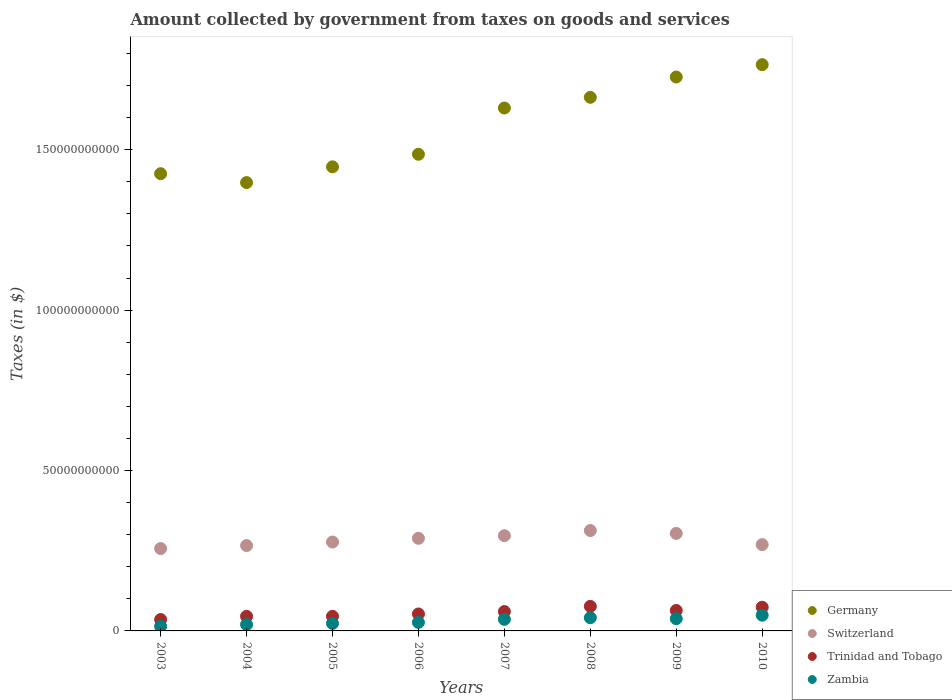What is the amount collected by government from taxes on goods and services in Zambia in 2006?
Your answer should be very brief. 2.66e+09. Across all years, what is the maximum amount collected by government from taxes on goods and services in Switzerland?
Keep it short and to the point. 3.13e+1. Across all years, what is the minimum amount collected by government from taxes on goods and services in Trinidad and Tobago?
Ensure brevity in your answer.  3.56e+09. In which year was the amount collected by government from taxes on goods and services in Germany maximum?
Keep it short and to the point. 2010. In which year was the amount collected by government from taxes on goods and services in Germany minimum?
Offer a very short reply. 2004. What is the total amount collected by government from taxes on goods and services in Switzerland in the graph?
Your response must be concise. 2.27e+11. What is the difference between the amount collected by government from taxes on goods and services in Zambia in 2005 and that in 2007?
Give a very brief answer. -1.28e+09. What is the difference between the amount collected by government from taxes on goods and services in Switzerland in 2005 and the amount collected by government from taxes on goods and services in Zambia in 2010?
Your response must be concise. 2.28e+1. What is the average amount collected by government from taxes on goods and services in Zambia per year?
Make the answer very short. 3.11e+09. In the year 2008, what is the difference between the amount collected by government from taxes on goods and services in Germany and amount collected by government from taxes on goods and services in Switzerland?
Offer a very short reply. 1.35e+11. In how many years, is the amount collected by government from taxes on goods and services in Switzerland greater than 90000000000 $?
Your answer should be compact. 0. What is the ratio of the amount collected by government from taxes on goods and services in Trinidad and Tobago in 2007 to that in 2009?
Offer a terse response. 0.95. What is the difference between the highest and the second highest amount collected by government from taxes on goods and services in Germany?
Ensure brevity in your answer.  3.85e+09. What is the difference between the highest and the lowest amount collected by government from taxes on goods and services in Germany?
Your response must be concise. 3.68e+1. Is it the case that in every year, the sum of the amount collected by government from taxes on goods and services in Switzerland and amount collected by government from taxes on goods and services in Zambia  is greater than the sum of amount collected by government from taxes on goods and services in Germany and amount collected by government from taxes on goods and services in Trinidad and Tobago?
Ensure brevity in your answer.  No. Is it the case that in every year, the sum of the amount collected by government from taxes on goods and services in Zambia and amount collected by government from taxes on goods and services in Germany  is greater than the amount collected by government from taxes on goods and services in Switzerland?
Offer a very short reply. Yes. Does the amount collected by government from taxes on goods and services in Trinidad and Tobago monotonically increase over the years?
Provide a short and direct response. No. Is the amount collected by government from taxes on goods and services in Germany strictly less than the amount collected by government from taxes on goods and services in Zambia over the years?
Provide a short and direct response. No. How many dotlines are there?
Make the answer very short. 4. What is the difference between two consecutive major ticks on the Y-axis?
Offer a very short reply. 5.00e+1. Are the values on the major ticks of Y-axis written in scientific E-notation?
Your response must be concise. No. How many legend labels are there?
Offer a terse response. 4. What is the title of the graph?
Provide a short and direct response. Amount collected by government from taxes on goods and services. What is the label or title of the X-axis?
Offer a very short reply. Years. What is the label or title of the Y-axis?
Your answer should be very brief. Taxes (in $). What is the Taxes (in $) of Germany in 2003?
Your answer should be very brief. 1.43e+11. What is the Taxes (in $) in Switzerland in 2003?
Offer a very short reply. 2.57e+1. What is the Taxes (in $) of Trinidad and Tobago in 2003?
Provide a short and direct response. 3.56e+09. What is the Taxes (in $) in Zambia in 2003?
Your answer should be compact. 1.42e+09. What is the Taxes (in $) in Germany in 2004?
Provide a short and direct response. 1.40e+11. What is the Taxes (in $) in Switzerland in 2004?
Make the answer very short. 2.66e+1. What is the Taxes (in $) in Trinidad and Tobago in 2004?
Your answer should be compact. 4.55e+09. What is the Taxes (in $) in Zambia in 2004?
Offer a very short reply. 1.99e+09. What is the Taxes (in $) of Germany in 2005?
Keep it short and to the point. 1.45e+11. What is the Taxes (in $) in Switzerland in 2005?
Offer a terse response. 2.77e+1. What is the Taxes (in $) in Trinidad and Tobago in 2005?
Provide a short and direct response. 4.56e+09. What is the Taxes (in $) of Zambia in 2005?
Give a very brief answer. 2.34e+09. What is the Taxes (in $) of Germany in 2006?
Give a very brief answer. 1.49e+11. What is the Taxes (in $) of Switzerland in 2006?
Ensure brevity in your answer.  2.89e+1. What is the Taxes (in $) of Trinidad and Tobago in 2006?
Provide a succinct answer. 5.29e+09. What is the Taxes (in $) of Zambia in 2006?
Your answer should be compact. 2.66e+09. What is the Taxes (in $) in Germany in 2007?
Your response must be concise. 1.63e+11. What is the Taxes (in $) in Switzerland in 2007?
Your response must be concise. 2.97e+1. What is the Taxes (in $) of Trinidad and Tobago in 2007?
Your response must be concise. 6.04e+09. What is the Taxes (in $) in Zambia in 2007?
Make the answer very short. 3.62e+09. What is the Taxes (in $) of Germany in 2008?
Ensure brevity in your answer.  1.66e+11. What is the Taxes (in $) in Switzerland in 2008?
Keep it short and to the point. 3.13e+1. What is the Taxes (in $) of Trinidad and Tobago in 2008?
Make the answer very short. 7.66e+09. What is the Taxes (in $) in Zambia in 2008?
Provide a succinct answer. 4.11e+09. What is the Taxes (in $) of Germany in 2009?
Give a very brief answer. 1.73e+11. What is the Taxes (in $) of Switzerland in 2009?
Provide a short and direct response. 3.04e+1. What is the Taxes (in $) in Trinidad and Tobago in 2009?
Your response must be concise. 6.38e+09. What is the Taxes (in $) in Zambia in 2009?
Your answer should be very brief. 3.82e+09. What is the Taxes (in $) in Germany in 2010?
Offer a terse response. 1.77e+11. What is the Taxes (in $) of Switzerland in 2010?
Offer a terse response. 2.69e+1. What is the Taxes (in $) in Trinidad and Tobago in 2010?
Give a very brief answer. 7.38e+09. What is the Taxes (in $) in Zambia in 2010?
Offer a terse response. 4.90e+09. Across all years, what is the maximum Taxes (in $) in Germany?
Make the answer very short. 1.77e+11. Across all years, what is the maximum Taxes (in $) of Switzerland?
Offer a terse response. 3.13e+1. Across all years, what is the maximum Taxes (in $) of Trinidad and Tobago?
Your answer should be very brief. 7.66e+09. Across all years, what is the maximum Taxes (in $) of Zambia?
Ensure brevity in your answer.  4.90e+09. Across all years, what is the minimum Taxes (in $) of Germany?
Give a very brief answer. 1.40e+11. Across all years, what is the minimum Taxes (in $) of Switzerland?
Your answer should be very brief. 2.57e+1. Across all years, what is the minimum Taxes (in $) in Trinidad and Tobago?
Your answer should be very brief. 3.56e+09. Across all years, what is the minimum Taxes (in $) of Zambia?
Your answer should be very brief. 1.42e+09. What is the total Taxes (in $) in Germany in the graph?
Keep it short and to the point. 1.25e+12. What is the total Taxes (in $) of Switzerland in the graph?
Offer a terse response. 2.27e+11. What is the total Taxes (in $) of Trinidad and Tobago in the graph?
Keep it short and to the point. 4.54e+1. What is the total Taxes (in $) in Zambia in the graph?
Your response must be concise. 2.49e+1. What is the difference between the Taxes (in $) of Germany in 2003 and that in 2004?
Offer a very short reply. 2.77e+09. What is the difference between the Taxes (in $) in Switzerland in 2003 and that in 2004?
Your response must be concise. -9.29e+08. What is the difference between the Taxes (in $) in Trinidad and Tobago in 2003 and that in 2004?
Provide a succinct answer. -9.94e+08. What is the difference between the Taxes (in $) in Zambia in 2003 and that in 2004?
Make the answer very short. -5.71e+08. What is the difference between the Taxes (in $) of Germany in 2003 and that in 2005?
Ensure brevity in your answer.  -2.14e+09. What is the difference between the Taxes (in $) in Switzerland in 2003 and that in 2005?
Provide a short and direct response. -2.03e+09. What is the difference between the Taxes (in $) in Trinidad and Tobago in 2003 and that in 2005?
Make the answer very short. -9.95e+08. What is the difference between the Taxes (in $) in Zambia in 2003 and that in 2005?
Your response must be concise. -9.25e+08. What is the difference between the Taxes (in $) in Germany in 2003 and that in 2006?
Offer a very short reply. -6.06e+09. What is the difference between the Taxes (in $) in Switzerland in 2003 and that in 2006?
Provide a succinct answer. -3.19e+09. What is the difference between the Taxes (in $) in Trinidad and Tobago in 2003 and that in 2006?
Ensure brevity in your answer.  -1.73e+09. What is the difference between the Taxes (in $) in Zambia in 2003 and that in 2006?
Keep it short and to the point. -1.24e+09. What is the difference between the Taxes (in $) in Germany in 2003 and that in 2007?
Keep it short and to the point. -2.05e+1. What is the difference between the Taxes (in $) in Switzerland in 2003 and that in 2007?
Provide a short and direct response. -4.01e+09. What is the difference between the Taxes (in $) in Trinidad and Tobago in 2003 and that in 2007?
Make the answer very short. -2.48e+09. What is the difference between the Taxes (in $) in Zambia in 2003 and that in 2007?
Keep it short and to the point. -2.20e+09. What is the difference between the Taxes (in $) in Germany in 2003 and that in 2008?
Your response must be concise. -2.38e+1. What is the difference between the Taxes (in $) of Switzerland in 2003 and that in 2008?
Provide a succinct answer. -5.62e+09. What is the difference between the Taxes (in $) in Trinidad and Tobago in 2003 and that in 2008?
Make the answer very short. -4.10e+09. What is the difference between the Taxes (in $) in Zambia in 2003 and that in 2008?
Offer a terse response. -2.70e+09. What is the difference between the Taxes (in $) of Germany in 2003 and that in 2009?
Offer a terse response. -3.01e+1. What is the difference between the Taxes (in $) in Switzerland in 2003 and that in 2009?
Ensure brevity in your answer.  -4.72e+09. What is the difference between the Taxes (in $) in Trinidad and Tobago in 2003 and that in 2009?
Make the answer very short. -2.82e+09. What is the difference between the Taxes (in $) of Zambia in 2003 and that in 2009?
Your answer should be very brief. -2.41e+09. What is the difference between the Taxes (in $) of Germany in 2003 and that in 2010?
Offer a terse response. -3.40e+1. What is the difference between the Taxes (in $) in Switzerland in 2003 and that in 2010?
Your answer should be very brief. -1.22e+09. What is the difference between the Taxes (in $) in Trinidad and Tobago in 2003 and that in 2010?
Your response must be concise. -3.82e+09. What is the difference between the Taxes (in $) in Zambia in 2003 and that in 2010?
Give a very brief answer. -3.49e+09. What is the difference between the Taxes (in $) of Germany in 2004 and that in 2005?
Your answer should be very brief. -4.91e+09. What is the difference between the Taxes (in $) of Switzerland in 2004 and that in 2005?
Offer a terse response. -1.11e+09. What is the difference between the Taxes (in $) of Trinidad and Tobago in 2004 and that in 2005?
Ensure brevity in your answer.  -1.20e+06. What is the difference between the Taxes (in $) of Zambia in 2004 and that in 2005?
Your answer should be very brief. -3.54e+08. What is the difference between the Taxes (in $) in Germany in 2004 and that in 2006?
Provide a succinct answer. -8.83e+09. What is the difference between the Taxes (in $) in Switzerland in 2004 and that in 2006?
Offer a terse response. -2.26e+09. What is the difference between the Taxes (in $) in Trinidad and Tobago in 2004 and that in 2006?
Your answer should be compact. -7.32e+08. What is the difference between the Taxes (in $) of Zambia in 2004 and that in 2006?
Ensure brevity in your answer.  -6.70e+08. What is the difference between the Taxes (in $) of Germany in 2004 and that in 2007?
Offer a terse response. -2.32e+1. What is the difference between the Taxes (in $) in Switzerland in 2004 and that in 2007?
Ensure brevity in your answer.  -3.08e+09. What is the difference between the Taxes (in $) of Trinidad and Tobago in 2004 and that in 2007?
Make the answer very short. -1.48e+09. What is the difference between the Taxes (in $) of Zambia in 2004 and that in 2007?
Your answer should be compact. -1.63e+09. What is the difference between the Taxes (in $) in Germany in 2004 and that in 2008?
Give a very brief answer. -2.66e+1. What is the difference between the Taxes (in $) in Switzerland in 2004 and that in 2008?
Provide a short and direct response. -4.69e+09. What is the difference between the Taxes (in $) of Trinidad and Tobago in 2004 and that in 2008?
Provide a succinct answer. -3.11e+09. What is the difference between the Taxes (in $) in Zambia in 2004 and that in 2008?
Offer a terse response. -2.13e+09. What is the difference between the Taxes (in $) of Germany in 2004 and that in 2009?
Offer a terse response. -3.29e+1. What is the difference between the Taxes (in $) in Switzerland in 2004 and that in 2009?
Ensure brevity in your answer.  -3.79e+09. What is the difference between the Taxes (in $) in Trinidad and Tobago in 2004 and that in 2009?
Keep it short and to the point. -1.82e+09. What is the difference between the Taxes (in $) in Zambia in 2004 and that in 2009?
Offer a terse response. -1.84e+09. What is the difference between the Taxes (in $) of Germany in 2004 and that in 2010?
Offer a terse response. -3.68e+1. What is the difference between the Taxes (in $) in Switzerland in 2004 and that in 2010?
Your answer should be compact. -2.95e+08. What is the difference between the Taxes (in $) of Trinidad and Tobago in 2004 and that in 2010?
Offer a terse response. -2.83e+09. What is the difference between the Taxes (in $) of Zambia in 2004 and that in 2010?
Offer a terse response. -2.91e+09. What is the difference between the Taxes (in $) in Germany in 2005 and that in 2006?
Provide a succinct answer. -3.92e+09. What is the difference between the Taxes (in $) of Switzerland in 2005 and that in 2006?
Make the answer very short. -1.15e+09. What is the difference between the Taxes (in $) of Trinidad and Tobago in 2005 and that in 2006?
Your answer should be very brief. -7.30e+08. What is the difference between the Taxes (in $) in Zambia in 2005 and that in 2006?
Your answer should be very brief. -3.15e+08. What is the difference between the Taxes (in $) of Germany in 2005 and that in 2007?
Your answer should be very brief. -1.83e+1. What is the difference between the Taxes (in $) in Switzerland in 2005 and that in 2007?
Ensure brevity in your answer.  -1.97e+09. What is the difference between the Taxes (in $) in Trinidad and Tobago in 2005 and that in 2007?
Your answer should be very brief. -1.48e+09. What is the difference between the Taxes (in $) of Zambia in 2005 and that in 2007?
Keep it short and to the point. -1.28e+09. What is the difference between the Taxes (in $) in Germany in 2005 and that in 2008?
Your answer should be very brief. -2.17e+1. What is the difference between the Taxes (in $) of Switzerland in 2005 and that in 2008?
Your response must be concise. -3.58e+09. What is the difference between the Taxes (in $) in Trinidad and Tobago in 2005 and that in 2008?
Provide a succinct answer. -3.10e+09. What is the difference between the Taxes (in $) in Zambia in 2005 and that in 2008?
Make the answer very short. -1.77e+09. What is the difference between the Taxes (in $) of Germany in 2005 and that in 2009?
Keep it short and to the point. -2.80e+1. What is the difference between the Taxes (in $) of Switzerland in 2005 and that in 2009?
Provide a short and direct response. -2.68e+09. What is the difference between the Taxes (in $) in Trinidad and Tobago in 2005 and that in 2009?
Ensure brevity in your answer.  -1.82e+09. What is the difference between the Taxes (in $) of Zambia in 2005 and that in 2009?
Your answer should be very brief. -1.48e+09. What is the difference between the Taxes (in $) in Germany in 2005 and that in 2010?
Offer a very short reply. -3.18e+1. What is the difference between the Taxes (in $) in Switzerland in 2005 and that in 2010?
Keep it short and to the point. 8.11e+08. What is the difference between the Taxes (in $) of Trinidad and Tobago in 2005 and that in 2010?
Make the answer very short. -2.83e+09. What is the difference between the Taxes (in $) in Zambia in 2005 and that in 2010?
Your answer should be very brief. -2.56e+09. What is the difference between the Taxes (in $) of Germany in 2006 and that in 2007?
Offer a terse response. -1.44e+1. What is the difference between the Taxes (in $) in Switzerland in 2006 and that in 2007?
Offer a very short reply. -8.22e+08. What is the difference between the Taxes (in $) in Trinidad and Tobago in 2006 and that in 2007?
Provide a succinct answer. -7.52e+08. What is the difference between the Taxes (in $) in Zambia in 2006 and that in 2007?
Ensure brevity in your answer.  -9.62e+08. What is the difference between the Taxes (in $) of Germany in 2006 and that in 2008?
Provide a short and direct response. -1.78e+1. What is the difference between the Taxes (in $) of Switzerland in 2006 and that in 2008?
Ensure brevity in your answer.  -2.43e+09. What is the difference between the Taxes (in $) of Trinidad and Tobago in 2006 and that in 2008?
Your answer should be very brief. -2.37e+09. What is the difference between the Taxes (in $) in Zambia in 2006 and that in 2008?
Ensure brevity in your answer.  -1.46e+09. What is the difference between the Taxes (in $) in Germany in 2006 and that in 2009?
Your answer should be compact. -2.41e+1. What is the difference between the Taxes (in $) of Switzerland in 2006 and that in 2009?
Give a very brief answer. -1.53e+09. What is the difference between the Taxes (in $) of Trinidad and Tobago in 2006 and that in 2009?
Your response must be concise. -1.09e+09. What is the difference between the Taxes (in $) of Zambia in 2006 and that in 2009?
Offer a very short reply. -1.17e+09. What is the difference between the Taxes (in $) in Germany in 2006 and that in 2010?
Provide a succinct answer. -2.79e+1. What is the difference between the Taxes (in $) in Switzerland in 2006 and that in 2010?
Ensure brevity in your answer.  1.96e+09. What is the difference between the Taxes (in $) of Trinidad and Tobago in 2006 and that in 2010?
Provide a succinct answer. -2.10e+09. What is the difference between the Taxes (in $) of Zambia in 2006 and that in 2010?
Provide a succinct answer. -2.24e+09. What is the difference between the Taxes (in $) of Germany in 2007 and that in 2008?
Your answer should be very brief. -3.33e+09. What is the difference between the Taxes (in $) in Switzerland in 2007 and that in 2008?
Keep it short and to the point. -1.61e+09. What is the difference between the Taxes (in $) of Trinidad and Tobago in 2007 and that in 2008?
Ensure brevity in your answer.  -1.62e+09. What is the difference between the Taxes (in $) in Zambia in 2007 and that in 2008?
Offer a very short reply. -4.95e+08. What is the difference between the Taxes (in $) in Germany in 2007 and that in 2009?
Provide a short and direct response. -9.66e+09. What is the difference between the Taxes (in $) in Switzerland in 2007 and that in 2009?
Offer a terse response. -7.08e+08. What is the difference between the Taxes (in $) of Trinidad and Tobago in 2007 and that in 2009?
Your response must be concise. -3.38e+08. What is the difference between the Taxes (in $) of Zambia in 2007 and that in 2009?
Your response must be concise. -2.04e+08. What is the difference between the Taxes (in $) of Germany in 2007 and that in 2010?
Provide a short and direct response. -1.35e+1. What is the difference between the Taxes (in $) in Switzerland in 2007 and that in 2010?
Make the answer very short. 2.79e+09. What is the difference between the Taxes (in $) in Trinidad and Tobago in 2007 and that in 2010?
Make the answer very short. -1.35e+09. What is the difference between the Taxes (in $) of Zambia in 2007 and that in 2010?
Ensure brevity in your answer.  -1.28e+09. What is the difference between the Taxes (in $) of Germany in 2008 and that in 2009?
Keep it short and to the point. -6.33e+09. What is the difference between the Taxes (in $) of Switzerland in 2008 and that in 2009?
Offer a very short reply. 9.00e+08. What is the difference between the Taxes (in $) in Trinidad and Tobago in 2008 and that in 2009?
Provide a short and direct response. 1.28e+09. What is the difference between the Taxes (in $) in Zambia in 2008 and that in 2009?
Offer a terse response. 2.91e+08. What is the difference between the Taxes (in $) in Germany in 2008 and that in 2010?
Provide a short and direct response. -1.02e+1. What is the difference between the Taxes (in $) in Switzerland in 2008 and that in 2010?
Your answer should be compact. 4.39e+09. What is the difference between the Taxes (in $) of Trinidad and Tobago in 2008 and that in 2010?
Give a very brief answer. 2.76e+08. What is the difference between the Taxes (in $) in Zambia in 2008 and that in 2010?
Provide a short and direct response. -7.88e+08. What is the difference between the Taxes (in $) of Germany in 2009 and that in 2010?
Give a very brief answer. -3.85e+09. What is the difference between the Taxes (in $) of Switzerland in 2009 and that in 2010?
Your response must be concise. 3.49e+09. What is the difference between the Taxes (in $) in Trinidad and Tobago in 2009 and that in 2010?
Your response must be concise. -1.01e+09. What is the difference between the Taxes (in $) in Zambia in 2009 and that in 2010?
Provide a succinct answer. -1.08e+09. What is the difference between the Taxes (in $) of Germany in 2003 and the Taxes (in $) of Switzerland in 2004?
Your answer should be compact. 1.16e+11. What is the difference between the Taxes (in $) in Germany in 2003 and the Taxes (in $) in Trinidad and Tobago in 2004?
Keep it short and to the point. 1.38e+11. What is the difference between the Taxes (in $) of Germany in 2003 and the Taxes (in $) of Zambia in 2004?
Provide a short and direct response. 1.41e+11. What is the difference between the Taxes (in $) in Switzerland in 2003 and the Taxes (in $) in Trinidad and Tobago in 2004?
Provide a succinct answer. 2.11e+1. What is the difference between the Taxes (in $) in Switzerland in 2003 and the Taxes (in $) in Zambia in 2004?
Provide a succinct answer. 2.37e+1. What is the difference between the Taxes (in $) in Trinidad and Tobago in 2003 and the Taxes (in $) in Zambia in 2004?
Ensure brevity in your answer.  1.57e+09. What is the difference between the Taxes (in $) of Germany in 2003 and the Taxes (in $) of Switzerland in 2005?
Provide a short and direct response. 1.15e+11. What is the difference between the Taxes (in $) in Germany in 2003 and the Taxes (in $) in Trinidad and Tobago in 2005?
Provide a succinct answer. 1.38e+11. What is the difference between the Taxes (in $) in Germany in 2003 and the Taxes (in $) in Zambia in 2005?
Offer a terse response. 1.40e+11. What is the difference between the Taxes (in $) in Switzerland in 2003 and the Taxes (in $) in Trinidad and Tobago in 2005?
Keep it short and to the point. 2.11e+1. What is the difference between the Taxes (in $) in Switzerland in 2003 and the Taxes (in $) in Zambia in 2005?
Offer a very short reply. 2.33e+1. What is the difference between the Taxes (in $) of Trinidad and Tobago in 2003 and the Taxes (in $) of Zambia in 2005?
Your answer should be very brief. 1.22e+09. What is the difference between the Taxes (in $) in Germany in 2003 and the Taxes (in $) in Switzerland in 2006?
Provide a succinct answer. 1.14e+11. What is the difference between the Taxes (in $) in Germany in 2003 and the Taxes (in $) in Trinidad and Tobago in 2006?
Keep it short and to the point. 1.37e+11. What is the difference between the Taxes (in $) in Germany in 2003 and the Taxes (in $) in Zambia in 2006?
Give a very brief answer. 1.40e+11. What is the difference between the Taxes (in $) of Switzerland in 2003 and the Taxes (in $) of Trinidad and Tobago in 2006?
Offer a terse response. 2.04e+1. What is the difference between the Taxes (in $) of Switzerland in 2003 and the Taxes (in $) of Zambia in 2006?
Provide a succinct answer. 2.30e+1. What is the difference between the Taxes (in $) of Trinidad and Tobago in 2003 and the Taxes (in $) of Zambia in 2006?
Give a very brief answer. 9.04e+08. What is the difference between the Taxes (in $) of Germany in 2003 and the Taxes (in $) of Switzerland in 2007?
Keep it short and to the point. 1.13e+11. What is the difference between the Taxes (in $) in Germany in 2003 and the Taxes (in $) in Trinidad and Tobago in 2007?
Offer a very short reply. 1.36e+11. What is the difference between the Taxes (in $) in Germany in 2003 and the Taxes (in $) in Zambia in 2007?
Your answer should be compact. 1.39e+11. What is the difference between the Taxes (in $) in Switzerland in 2003 and the Taxes (in $) in Trinidad and Tobago in 2007?
Keep it short and to the point. 1.96e+1. What is the difference between the Taxes (in $) of Switzerland in 2003 and the Taxes (in $) of Zambia in 2007?
Your response must be concise. 2.21e+1. What is the difference between the Taxes (in $) in Trinidad and Tobago in 2003 and the Taxes (in $) in Zambia in 2007?
Offer a terse response. -5.76e+07. What is the difference between the Taxes (in $) in Germany in 2003 and the Taxes (in $) in Switzerland in 2008?
Offer a very short reply. 1.11e+11. What is the difference between the Taxes (in $) of Germany in 2003 and the Taxes (in $) of Trinidad and Tobago in 2008?
Provide a succinct answer. 1.35e+11. What is the difference between the Taxes (in $) in Germany in 2003 and the Taxes (in $) in Zambia in 2008?
Make the answer very short. 1.38e+11. What is the difference between the Taxes (in $) of Switzerland in 2003 and the Taxes (in $) of Trinidad and Tobago in 2008?
Your answer should be very brief. 1.80e+1. What is the difference between the Taxes (in $) of Switzerland in 2003 and the Taxes (in $) of Zambia in 2008?
Make the answer very short. 2.16e+1. What is the difference between the Taxes (in $) in Trinidad and Tobago in 2003 and the Taxes (in $) in Zambia in 2008?
Offer a very short reply. -5.53e+08. What is the difference between the Taxes (in $) of Germany in 2003 and the Taxes (in $) of Switzerland in 2009?
Your answer should be compact. 1.12e+11. What is the difference between the Taxes (in $) in Germany in 2003 and the Taxes (in $) in Trinidad and Tobago in 2009?
Provide a succinct answer. 1.36e+11. What is the difference between the Taxes (in $) in Germany in 2003 and the Taxes (in $) in Zambia in 2009?
Offer a terse response. 1.39e+11. What is the difference between the Taxes (in $) of Switzerland in 2003 and the Taxes (in $) of Trinidad and Tobago in 2009?
Provide a short and direct response. 1.93e+1. What is the difference between the Taxes (in $) in Switzerland in 2003 and the Taxes (in $) in Zambia in 2009?
Offer a terse response. 2.19e+1. What is the difference between the Taxes (in $) of Trinidad and Tobago in 2003 and the Taxes (in $) of Zambia in 2009?
Your response must be concise. -2.62e+08. What is the difference between the Taxes (in $) in Germany in 2003 and the Taxes (in $) in Switzerland in 2010?
Offer a very short reply. 1.16e+11. What is the difference between the Taxes (in $) of Germany in 2003 and the Taxes (in $) of Trinidad and Tobago in 2010?
Offer a very short reply. 1.35e+11. What is the difference between the Taxes (in $) in Germany in 2003 and the Taxes (in $) in Zambia in 2010?
Offer a very short reply. 1.38e+11. What is the difference between the Taxes (in $) in Switzerland in 2003 and the Taxes (in $) in Trinidad and Tobago in 2010?
Ensure brevity in your answer.  1.83e+1. What is the difference between the Taxes (in $) of Switzerland in 2003 and the Taxes (in $) of Zambia in 2010?
Offer a terse response. 2.08e+1. What is the difference between the Taxes (in $) in Trinidad and Tobago in 2003 and the Taxes (in $) in Zambia in 2010?
Your answer should be compact. -1.34e+09. What is the difference between the Taxes (in $) of Germany in 2004 and the Taxes (in $) of Switzerland in 2005?
Provide a succinct answer. 1.12e+11. What is the difference between the Taxes (in $) of Germany in 2004 and the Taxes (in $) of Trinidad and Tobago in 2005?
Provide a short and direct response. 1.35e+11. What is the difference between the Taxes (in $) of Germany in 2004 and the Taxes (in $) of Zambia in 2005?
Provide a short and direct response. 1.37e+11. What is the difference between the Taxes (in $) of Switzerland in 2004 and the Taxes (in $) of Trinidad and Tobago in 2005?
Offer a terse response. 2.20e+1. What is the difference between the Taxes (in $) of Switzerland in 2004 and the Taxes (in $) of Zambia in 2005?
Ensure brevity in your answer.  2.43e+1. What is the difference between the Taxes (in $) in Trinidad and Tobago in 2004 and the Taxes (in $) in Zambia in 2005?
Your answer should be very brief. 2.21e+09. What is the difference between the Taxes (in $) in Germany in 2004 and the Taxes (in $) in Switzerland in 2006?
Your answer should be compact. 1.11e+11. What is the difference between the Taxes (in $) in Germany in 2004 and the Taxes (in $) in Trinidad and Tobago in 2006?
Your answer should be very brief. 1.34e+11. What is the difference between the Taxes (in $) in Germany in 2004 and the Taxes (in $) in Zambia in 2006?
Give a very brief answer. 1.37e+11. What is the difference between the Taxes (in $) of Switzerland in 2004 and the Taxes (in $) of Trinidad and Tobago in 2006?
Provide a succinct answer. 2.13e+1. What is the difference between the Taxes (in $) of Switzerland in 2004 and the Taxes (in $) of Zambia in 2006?
Keep it short and to the point. 2.39e+1. What is the difference between the Taxes (in $) in Trinidad and Tobago in 2004 and the Taxes (in $) in Zambia in 2006?
Offer a terse response. 1.90e+09. What is the difference between the Taxes (in $) of Germany in 2004 and the Taxes (in $) of Switzerland in 2007?
Provide a succinct answer. 1.10e+11. What is the difference between the Taxes (in $) of Germany in 2004 and the Taxes (in $) of Trinidad and Tobago in 2007?
Ensure brevity in your answer.  1.34e+11. What is the difference between the Taxes (in $) in Germany in 2004 and the Taxes (in $) in Zambia in 2007?
Provide a succinct answer. 1.36e+11. What is the difference between the Taxes (in $) in Switzerland in 2004 and the Taxes (in $) in Trinidad and Tobago in 2007?
Provide a succinct answer. 2.06e+1. What is the difference between the Taxes (in $) of Switzerland in 2004 and the Taxes (in $) of Zambia in 2007?
Keep it short and to the point. 2.30e+1. What is the difference between the Taxes (in $) in Trinidad and Tobago in 2004 and the Taxes (in $) in Zambia in 2007?
Keep it short and to the point. 9.37e+08. What is the difference between the Taxes (in $) in Germany in 2004 and the Taxes (in $) in Switzerland in 2008?
Ensure brevity in your answer.  1.08e+11. What is the difference between the Taxes (in $) of Germany in 2004 and the Taxes (in $) of Trinidad and Tobago in 2008?
Keep it short and to the point. 1.32e+11. What is the difference between the Taxes (in $) of Germany in 2004 and the Taxes (in $) of Zambia in 2008?
Provide a succinct answer. 1.36e+11. What is the difference between the Taxes (in $) in Switzerland in 2004 and the Taxes (in $) in Trinidad and Tobago in 2008?
Give a very brief answer. 1.89e+1. What is the difference between the Taxes (in $) of Switzerland in 2004 and the Taxes (in $) of Zambia in 2008?
Keep it short and to the point. 2.25e+1. What is the difference between the Taxes (in $) in Trinidad and Tobago in 2004 and the Taxes (in $) in Zambia in 2008?
Provide a succinct answer. 4.42e+08. What is the difference between the Taxes (in $) of Germany in 2004 and the Taxes (in $) of Switzerland in 2009?
Offer a terse response. 1.09e+11. What is the difference between the Taxes (in $) of Germany in 2004 and the Taxes (in $) of Trinidad and Tobago in 2009?
Give a very brief answer. 1.33e+11. What is the difference between the Taxes (in $) in Germany in 2004 and the Taxes (in $) in Zambia in 2009?
Your answer should be compact. 1.36e+11. What is the difference between the Taxes (in $) of Switzerland in 2004 and the Taxes (in $) of Trinidad and Tobago in 2009?
Provide a short and direct response. 2.02e+1. What is the difference between the Taxes (in $) in Switzerland in 2004 and the Taxes (in $) in Zambia in 2009?
Offer a very short reply. 2.28e+1. What is the difference between the Taxes (in $) in Trinidad and Tobago in 2004 and the Taxes (in $) in Zambia in 2009?
Give a very brief answer. 7.32e+08. What is the difference between the Taxes (in $) in Germany in 2004 and the Taxes (in $) in Switzerland in 2010?
Your answer should be very brief. 1.13e+11. What is the difference between the Taxes (in $) in Germany in 2004 and the Taxes (in $) in Trinidad and Tobago in 2010?
Your response must be concise. 1.32e+11. What is the difference between the Taxes (in $) of Germany in 2004 and the Taxes (in $) of Zambia in 2010?
Provide a succinct answer. 1.35e+11. What is the difference between the Taxes (in $) of Switzerland in 2004 and the Taxes (in $) of Trinidad and Tobago in 2010?
Provide a succinct answer. 1.92e+1. What is the difference between the Taxes (in $) in Switzerland in 2004 and the Taxes (in $) in Zambia in 2010?
Make the answer very short. 2.17e+1. What is the difference between the Taxes (in $) of Trinidad and Tobago in 2004 and the Taxes (in $) of Zambia in 2010?
Provide a short and direct response. -3.46e+08. What is the difference between the Taxes (in $) in Germany in 2005 and the Taxes (in $) in Switzerland in 2006?
Give a very brief answer. 1.16e+11. What is the difference between the Taxes (in $) of Germany in 2005 and the Taxes (in $) of Trinidad and Tobago in 2006?
Your answer should be very brief. 1.39e+11. What is the difference between the Taxes (in $) in Germany in 2005 and the Taxes (in $) in Zambia in 2006?
Give a very brief answer. 1.42e+11. What is the difference between the Taxes (in $) of Switzerland in 2005 and the Taxes (in $) of Trinidad and Tobago in 2006?
Your answer should be compact. 2.24e+1. What is the difference between the Taxes (in $) of Switzerland in 2005 and the Taxes (in $) of Zambia in 2006?
Your response must be concise. 2.51e+1. What is the difference between the Taxes (in $) in Trinidad and Tobago in 2005 and the Taxes (in $) in Zambia in 2006?
Give a very brief answer. 1.90e+09. What is the difference between the Taxes (in $) in Germany in 2005 and the Taxes (in $) in Switzerland in 2007?
Your answer should be compact. 1.15e+11. What is the difference between the Taxes (in $) of Germany in 2005 and the Taxes (in $) of Trinidad and Tobago in 2007?
Ensure brevity in your answer.  1.39e+11. What is the difference between the Taxes (in $) in Germany in 2005 and the Taxes (in $) in Zambia in 2007?
Offer a terse response. 1.41e+11. What is the difference between the Taxes (in $) in Switzerland in 2005 and the Taxes (in $) in Trinidad and Tobago in 2007?
Provide a succinct answer. 2.17e+1. What is the difference between the Taxes (in $) in Switzerland in 2005 and the Taxes (in $) in Zambia in 2007?
Keep it short and to the point. 2.41e+1. What is the difference between the Taxes (in $) of Trinidad and Tobago in 2005 and the Taxes (in $) of Zambia in 2007?
Provide a succinct answer. 9.38e+08. What is the difference between the Taxes (in $) of Germany in 2005 and the Taxes (in $) of Switzerland in 2008?
Offer a very short reply. 1.13e+11. What is the difference between the Taxes (in $) of Germany in 2005 and the Taxes (in $) of Trinidad and Tobago in 2008?
Keep it short and to the point. 1.37e+11. What is the difference between the Taxes (in $) in Germany in 2005 and the Taxes (in $) in Zambia in 2008?
Ensure brevity in your answer.  1.41e+11. What is the difference between the Taxes (in $) of Switzerland in 2005 and the Taxes (in $) of Trinidad and Tobago in 2008?
Your answer should be compact. 2.01e+1. What is the difference between the Taxes (in $) of Switzerland in 2005 and the Taxes (in $) of Zambia in 2008?
Offer a terse response. 2.36e+1. What is the difference between the Taxes (in $) of Trinidad and Tobago in 2005 and the Taxes (in $) of Zambia in 2008?
Give a very brief answer. 4.43e+08. What is the difference between the Taxes (in $) in Germany in 2005 and the Taxes (in $) in Switzerland in 2009?
Your answer should be compact. 1.14e+11. What is the difference between the Taxes (in $) of Germany in 2005 and the Taxes (in $) of Trinidad and Tobago in 2009?
Ensure brevity in your answer.  1.38e+11. What is the difference between the Taxes (in $) of Germany in 2005 and the Taxes (in $) of Zambia in 2009?
Give a very brief answer. 1.41e+11. What is the difference between the Taxes (in $) in Switzerland in 2005 and the Taxes (in $) in Trinidad and Tobago in 2009?
Provide a short and direct response. 2.13e+1. What is the difference between the Taxes (in $) of Switzerland in 2005 and the Taxes (in $) of Zambia in 2009?
Your answer should be compact. 2.39e+1. What is the difference between the Taxes (in $) in Trinidad and Tobago in 2005 and the Taxes (in $) in Zambia in 2009?
Your response must be concise. 7.34e+08. What is the difference between the Taxes (in $) in Germany in 2005 and the Taxes (in $) in Switzerland in 2010?
Keep it short and to the point. 1.18e+11. What is the difference between the Taxes (in $) in Germany in 2005 and the Taxes (in $) in Trinidad and Tobago in 2010?
Your answer should be very brief. 1.37e+11. What is the difference between the Taxes (in $) of Germany in 2005 and the Taxes (in $) of Zambia in 2010?
Give a very brief answer. 1.40e+11. What is the difference between the Taxes (in $) in Switzerland in 2005 and the Taxes (in $) in Trinidad and Tobago in 2010?
Your response must be concise. 2.03e+1. What is the difference between the Taxes (in $) in Switzerland in 2005 and the Taxes (in $) in Zambia in 2010?
Give a very brief answer. 2.28e+1. What is the difference between the Taxes (in $) of Trinidad and Tobago in 2005 and the Taxes (in $) of Zambia in 2010?
Offer a very short reply. -3.45e+08. What is the difference between the Taxes (in $) in Germany in 2006 and the Taxes (in $) in Switzerland in 2007?
Provide a succinct answer. 1.19e+11. What is the difference between the Taxes (in $) of Germany in 2006 and the Taxes (in $) of Trinidad and Tobago in 2007?
Make the answer very short. 1.43e+11. What is the difference between the Taxes (in $) of Germany in 2006 and the Taxes (in $) of Zambia in 2007?
Your response must be concise. 1.45e+11. What is the difference between the Taxes (in $) in Switzerland in 2006 and the Taxes (in $) in Trinidad and Tobago in 2007?
Provide a short and direct response. 2.28e+1. What is the difference between the Taxes (in $) in Switzerland in 2006 and the Taxes (in $) in Zambia in 2007?
Give a very brief answer. 2.52e+1. What is the difference between the Taxes (in $) of Trinidad and Tobago in 2006 and the Taxes (in $) of Zambia in 2007?
Offer a very short reply. 1.67e+09. What is the difference between the Taxes (in $) of Germany in 2006 and the Taxes (in $) of Switzerland in 2008?
Offer a terse response. 1.17e+11. What is the difference between the Taxes (in $) in Germany in 2006 and the Taxes (in $) in Trinidad and Tobago in 2008?
Your answer should be very brief. 1.41e+11. What is the difference between the Taxes (in $) of Germany in 2006 and the Taxes (in $) of Zambia in 2008?
Provide a short and direct response. 1.44e+11. What is the difference between the Taxes (in $) in Switzerland in 2006 and the Taxes (in $) in Trinidad and Tobago in 2008?
Make the answer very short. 2.12e+1. What is the difference between the Taxes (in $) of Switzerland in 2006 and the Taxes (in $) of Zambia in 2008?
Provide a succinct answer. 2.48e+1. What is the difference between the Taxes (in $) in Trinidad and Tobago in 2006 and the Taxes (in $) in Zambia in 2008?
Offer a terse response. 1.17e+09. What is the difference between the Taxes (in $) in Germany in 2006 and the Taxes (in $) in Switzerland in 2009?
Keep it short and to the point. 1.18e+11. What is the difference between the Taxes (in $) in Germany in 2006 and the Taxes (in $) in Trinidad and Tobago in 2009?
Provide a succinct answer. 1.42e+11. What is the difference between the Taxes (in $) of Germany in 2006 and the Taxes (in $) of Zambia in 2009?
Give a very brief answer. 1.45e+11. What is the difference between the Taxes (in $) in Switzerland in 2006 and the Taxes (in $) in Trinidad and Tobago in 2009?
Your answer should be compact. 2.25e+1. What is the difference between the Taxes (in $) in Switzerland in 2006 and the Taxes (in $) in Zambia in 2009?
Offer a very short reply. 2.50e+1. What is the difference between the Taxes (in $) in Trinidad and Tobago in 2006 and the Taxes (in $) in Zambia in 2009?
Your answer should be very brief. 1.46e+09. What is the difference between the Taxes (in $) in Germany in 2006 and the Taxes (in $) in Switzerland in 2010?
Give a very brief answer. 1.22e+11. What is the difference between the Taxes (in $) in Germany in 2006 and the Taxes (in $) in Trinidad and Tobago in 2010?
Ensure brevity in your answer.  1.41e+11. What is the difference between the Taxes (in $) of Germany in 2006 and the Taxes (in $) of Zambia in 2010?
Offer a very short reply. 1.44e+11. What is the difference between the Taxes (in $) in Switzerland in 2006 and the Taxes (in $) in Trinidad and Tobago in 2010?
Your answer should be compact. 2.15e+1. What is the difference between the Taxes (in $) in Switzerland in 2006 and the Taxes (in $) in Zambia in 2010?
Your answer should be very brief. 2.40e+1. What is the difference between the Taxes (in $) of Trinidad and Tobago in 2006 and the Taxes (in $) of Zambia in 2010?
Ensure brevity in your answer.  3.85e+08. What is the difference between the Taxes (in $) in Germany in 2007 and the Taxes (in $) in Switzerland in 2008?
Give a very brief answer. 1.32e+11. What is the difference between the Taxes (in $) in Germany in 2007 and the Taxes (in $) in Trinidad and Tobago in 2008?
Keep it short and to the point. 1.55e+11. What is the difference between the Taxes (in $) of Germany in 2007 and the Taxes (in $) of Zambia in 2008?
Your answer should be very brief. 1.59e+11. What is the difference between the Taxes (in $) in Switzerland in 2007 and the Taxes (in $) in Trinidad and Tobago in 2008?
Give a very brief answer. 2.20e+1. What is the difference between the Taxes (in $) of Switzerland in 2007 and the Taxes (in $) of Zambia in 2008?
Offer a terse response. 2.56e+1. What is the difference between the Taxes (in $) in Trinidad and Tobago in 2007 and the Taxes (in $) in Zambia in 2008?
Keep it short and to the point. 1.93e+09. What is the difference between the Taxes (in $) in Germany in 2007 and the Taxes (in $) in Switzerland in 2009?
Offer a very short reply. 1.33e+11. What is the difference between the Taxes (in $) of Germany in 2007 and the Taxes (in $) of Trinidad and Tobago in 2009?
Provide a short and direct response. 1.57e+11. What is the difference between the Taxes (in $) in Germany in 2007 and the Taxes (in $) in Zambia in 2009?
Provide a short and direct response. 1.59e+11. What is the difference between the Taxes (in $) in Switzerland in 2007 and the Taxes (in $) in Trinidad and Tobago in 2009?
Offer a terse response. 2.33e+1. What is the difference between the Taxes (in $) in Switzerland in 2007 and the Taxes (in $) in Zambia in 2009?
Offer a terse response. 2.59e+1. What is the difference between the Taxes (in $) of Trinidad and Tobago in 2007 and the Taxes (in $) of Zambia in 2009?
Provide a succinct answer. 2.22e+09. What is the difference between the Taxes (in $) in Germany in 2007 and the Taxes (in $) in Switzerland in 2010?
Your answer should be very brief. 1.36e+11. What is the difference between the Taxes (in $) of Germany in 2007 and the Taxes (in $) of Trinidad and Tobago in 2010?
Provide a short and direct response. 1.56e+11. What is the difference between the Taxes (in $) in Germany in 2007 and the Taxes (in $) in Zambia in 2010?
Offer a terse response. 1.58e+11. What is the difference between the Taxes (in $) of Switzerland in 2007 and the Taxes (in $) of Trinidad and Tobago in 2010?
Your answer should be very brief. 2.23e+1. What is the difference between the Taxes (in $) of Switzerland in 2007 and the Taxes (in $) of Zambia in 2010?
Your response must be concise. 2.48e+1. What is the difference between the Taxes (in $) in Trinidad and Tobago in 2007 and the Taxes (in $) in Zambia in 2010?
Your answer should be compact. 1.14e+09. What is the difference between the Taxes (in $) in Germany in 2008 and the Taxes (in $) in Switzerland in 2009?
Make the answer very short. 1.36e+11. What is the difference between the Taxes (in $) in Germany in 2008 and the Taxes (in $) in Trinidad and Tobago in 2009?
Your answer should be very brief. 1.60e+11. What is the difference between the Taxes (in $) in Germany in 2008 and the Taxes (in $) in Zambia in 2009?
Make the answer very short. 1.63e+11. What is the difference between the Taxes (in $) of Switzerland in 2008 and the Taxes (in $) of Trinidad and Tobago in 2009?
Make the answer very short. 2.49e+1. What is the difference between the Taxes (in $) in Switzerland in 2008 and the Taxes (in $) in Zambia in 2009?
Your answer should be very brief. 2.75e+1. What is the difference between the Taxes (in $) of Trinidad and Tobago in 2008 and the Taxes (in $) of Zambia in 2009?
Offer a very short reply. 3.84e+09. What is the difference between the Taxes (in $) in Germany in 2008 and the Taxes (in $) in Switzerland in 2010?
Ensure brevity in your answer.  1.39e+11. What is the difference between the Taxes (in $) in Germany in 2008 and the Taxes (in $) in Trinidad and Tobago in 2010?
Provide a short and direct response. 1.59e+11. What is the difference between the Taxes (in $) in Germany in 2008 and the Taxes (in $) in Zambia in 2010?
Your response must be concise. 1.61e+11. What is the difference between the Taxes (in $) in Switzerland in 2008 and the Taxes (in $) in Trinidad and Tobago in 2010?
Offer a very short reply. 2.39e+1. What is the difference between the Taxes (in $) of Switzerland in 2008 and the Taxes (in $) of Zambia in 2010?
Your answer should be very brief. 2.64e+1. What is the difference between the Taxes (in $) of Trinidad and Tobago in 2008 and the Taxes (in $) of Zambia in 2010?
Give a very brief answer. 2.76e+09. What is the difference between the Taxes (in $) in Germany in 2009 and the Taxes (in $) in Switzerland in 2010?
Offer a very short reply. 1.46e+11. What is the difference between the Taxes (in $) in Germany in 2009 and the Taxes (in $) in Trinidad and Tobago in 2010?
Ensure brevity in your answer.  1.65e+11. What is the difference between the Taxes (in $) of Germany in 2009 and the Taxes (in $) of Zambia in 2010?
Provide a short and direct response. 1.68e+11. What is the difference between the Taxes (in $) in Switzerland in 2009 and the Taxes (in $) in Trinidad and Tobago in 2010?
Offer a very short reply. 2.30e+1. What is the difference between the Taxes (in $) of Switzerland in 2009 and the Taxes (in $) of Zambia in 2010?
Your answer should be very brief. 2.55e+1. What is the difference between the Taxes (in $) of Trinidad and Tobago in 2009 and the Taxes (in $) of Zambia in 2010?
Offer a very short reply. 1.47e+09. What is the average Taxes (in $) in Germany per year?
Your response must be concise. 1.57e+11. What is the average Taxes (in $) in Switzerland per year?
Your answer should be compact. 2.84e+1. What is the average Taxes (in $) of Trinidad and Tobago per year?
Your response must be concise. 5.68e+09. What is the average Taxes (in $) of Zambia per year?
Your response must be concise. 3.11e+09. In the year 2003, what is the difference between the Taxes (in $) of Germany and Taxes (in $) of Switzerland?
Give a very brief answer. 1.17e+11. In the year 2003, what is the difference between the Taxes (in $) of Germany and Taxes (in $) of Trinidad and Tobago?
Offer a very short reply. 1.39e+11. In the year 2003, what is the difference between the Taxes (in $) in Germany and Taxes (in $) in Zambia?
Make the answer very short. 1.41e+11. In the year 2003, what is the difference between the Taxes (in $) in Switzerland and Taxes (in $) in Trinidad and Tobago?
Offer a terse response. 2.21e+1. In the year 2003, what is the difference between the Taxes (in $) in Switzerland and Taxes (in $) in Zambia?
Offer a terse response. 2.43e+1. In the year 2003, what is the difference between the Taxes (in $) of Trinidad and Tobago and Taxes (in $) of Zambia?
Keep it short and to the point. 2.14e+09. In the year 2004, what is the difference between the Taxes (in $) of Germany and Taxes (in $) of Switzerland?
Give a very brief answer. 1.13e+11. In the year 2004, what is the difference between the Taxes (in $) in Germany and Taxes (in $) in Trinidad and Tobago?
Your answer should be compact. 1.35e+11. In the year 2004, what is the difference between the Taxes (in $) of Germany and Taxes (in $) of Zambia?
Make the answer very short. 1.38e+11. In the year 2004, what is the difference between the Taxes (in $) in Switzerland and Taxes (in $) in Trinidad and Tobago?
Your answer should be compact. 2.21e+1. In the year 2004, what is the difference between the Taxes (in $) in Switzerland and Taxes (in $) in Zambia?
Ensure brevity in your answer.  2.46e+1. In the year 2004, what is the difference between the Taxes (in $) in Trinidad and Tobago and Taxes (in $) in Zambia?
Give a very brief answer. 2.57e+09. In the year 2005, what is the difference between the Taxes (in $) in Germany and Taxes (in $) in Switzerland?
Provide a short and direct response. 1.17e+11. In the year 2005, what is the difference between the Taxes (in $) of Germany and Taxes (in $) of Trinidad and Tobago?
Offer a very short reply. 1.40e+11. In the year 2005, what is the difference between the Taxes (in $) of Germany and Taxes (in $) of Zambia?
Make the answer very short. 1.42e+11. In the year 2005, what is the difference between the Taxes (in $) in Switzerland and Taxes (in $) in Trinidad and Tobago?
Ensure brevity in your answer.  2.32e+1. In the year 2005, what is the difference between the Taxes (in $) of Switzerland and Taxes (in $) of Zambia?
Keep it short and to the point. 2.54e+1. In the year 2005, what is the difference between the Taxes (in $) in Trinidad and Tobago and Taxes (in $) in Zambia?
Your answer should be very brief. 2.21e+09. In the year 2006, what is the difference between the Taxes (in $) in Germany and Taxes (in $) in Switzerland?
Keep it short and to the point. 1.20e+11. In the year 2006, what is the difference between the Taxes (in $) of Germany and Taxes (in $) of Trinidad and Tobago?
Keep it short and to the point. 1.43e+11. In the year 2006, what is the difference between the Taxes (in $) of Germany and Taxes (in $) of Zambia?
Ensure brevity in your answer.  1.46e+11. In the year 2006, what is the difference between the Taxes (in $) in Switzerland and Taxes (in $) in Trinidad and Tobago?
Your answer should be compact. 2.36e+1. In the year 2006, what is the difference between the Taxes (in $) of Switzerland and Taxes (in $) of Zambia?
Your response must be concise. 2.62e+1. In the year 2006, what is the difference between the Taxes (in $) of Trinidad and Tobago and Taxes (in $) of Zambia?
Offer a terse response. 2.63e+09. In the year 2007, what is the difference between the Taxes (in $) in Germany and Taxes (in $) in Switzerland?
Keep it short and to the point. 1.33e+11. In the year 2007, what is the difference between the Taxes (in $) in Germany and Taxes (in $) in Trinidad and Tobago?
Provide a short and direct response. 1.57e+11. In the year 2007, what is the difference between the Taxes (in $) in Germany and Taxes (in $) in Zambia?
Keep it short and to the point. 1.59e+11. In the year 2007, what is the difference between the Taxes (in $) of Switzerland and Taxes (in $) of Trinidad and Tobago?
Ensure brevity in your answer.  2.36e+1. In the year 2007, what is the difference between the Taxes (in $) of Switzerland and Taxes (in $) of Zambia?
Provide a short and direct response. 2.61e+1. In the year 2007, what is the difference between the Taxes (in $) of Trinidad and Tobago and Taxes (in $) of Zambia?
Make the answer very short. 2.42e+09. In the year 2008, what is the difference between the Taxes (in $) of Germany and Taxes (in $) of Switzerland?
Provide a succinct answer. 1.35e+11. In the year 2008, what is the difference between the Taxes (in $) of Germany and Taxes (in $) of Trinidad and Tobago?
Provide a short and direct response. 1.59e+11. In the year 2008, what is the difference between the Taxes (in $) of Germany and Taxes (in $) of Zambia?
Keep it short and to the point. 1.62e+11. In the year 2008, what is the difference between the Taxes (in $) of Switzerland and Taxes (in $) of Trinidad and Tobago?
Your answer should be very brief. 2.36e+1. In the year 2008, what is the difference between the Taxes (in $) in Switzerland and Taxes (in $) in Zambia?
Make the answer very short. 2.72e+1. In the year 2008, what is the difference between the Taxes (in $) in Trinidad and Tobago and Taxes (in $) in Zambia?
Your answer should be very brief. 3.55e+09. In the year 2009, what is the difference between the Taxes (in $) in Germany and Taxes (in $) in Switzerland?
Your answer should be very brief. 1.42e+11. In the year 2009, what is the difference between the Taxes (in $) of Germany and Taxes (in $) of Trinidad and Tobago?
Offer a terse response. 1.66e+11. In the year 2009, what is the difference between the Taxes (in $) in Germany and Taxes (in $) in Zambia?
Offer a terse response. 1.69e+11. In the year 2009, what is the difference between the Taxes (in $) in Switzerland and Taxes (in $) in Trinidad and Tobago?
Keep it short and to the point. 2.40e+1. In the year 2009, what is the difference between the Taxes (in $) in Switzerland and Taxes (in $) in Zambia?
Ensure brevity in your answer.  2.66e+1. In the year 2009, what is the difference between the Taxes (in $) in Trinidad and Tobago and Taxes (in $) in Zambia?
Your answer should be very brief. 2.55e+09. In the year 2010, what is the difference between the Taxes (in $) of Germany and Taxes (in $) of Switzerland?
Make the answer very short. 1.50e+11. In the year 2010, what is the difference between the Taxes (in $) of Germany and Taxes (in $) of Trinidad and Tobago?
Your answer should be very brief. 1.69e+11. In the year 2010, what is the difference between the Taxes (in $) in Germany and Taxes (in $) in Zambia?
Your response must be concise. 1.72e+11. In the year 2010, what is the difference between the Taxes (in $) in Switzerland and Taxes (in $) in Trinidad and Tobago?
Your response must be concise. 1.95e+1. In the year 2010, what is the difference between the Taxes (in $) in Switzerland and Taxes (in $) in Zambia?
Provide a short and direct response. 2.20e+1. In the year 2010, what is the difference between the Taxes (in $) in Trinidad and Tobago and Taxes (in $) in Zambia?
Provide a short and direct response. 2.48e+09. What is the ratio of the Taxes (in $) in Germany in 2003 to that in 2004?
Ensure brevity in your answer.  1.02. What is the ratio of the Taxes (in $) of Switzerland in 2003 to that in 2004?
Your answer should be very brief. 0.97. What is the ratio of the Taxes (in $) of Trinidad and Tobago in 2003 to that in 2004?
Make the answer very short. 0.78. What is the ratio of the Taxes (in $) in Zambia in 2003 to that in 2004?
Offer a terse response. 0.71. What is the ratio of the Taxes (in $) in Germany in 2003 to that in 2005?
Provide a short and direct response. 0.99. What is the ratio of the Taxes (in $) in Switzerland in 2003 to that in 2005?
Provide a succinct answer. 0.93. What is the ratio of the Taxes (in $) of Trinidad and Tobago in 2003 to that in 2005?
Offer a terse response. 0.78. What is the ratio of the Taxes (in $) of Zambia in 2003 to that in 2005?
Your response must be concise. 0.6. What is the ratio of the Taxes (in $) in Germany in 2003 to that in 2006?
Make the answer very short. 0.96. What is the ratio of the Taxes (in $) in Switzerland in 2003 to that in 2006?
Keep it short and to the point. 0.89. What is the ratio of the Taxes (in $) of Trinidad and Tobago in 2003 to that in 2006?
Give a very brief answer. 0.67. What is the ratio of the Taxes (in $) of Zambia in 2003 to that in 2006?
Provide a succinct answer. 0.53. What is the ratio of the Taxes (in $) of Germany in 2003 to that in 2007?
Your answer should be compact. 0.87. What is the ratio of the Taxes (in $) of Switzerland in 2003 to that in 2007?
Provide a succinct answer. 0.86. What is the ratio of the Taxes (in $) of Trinidad and Tobago in 2003 to that in 2007?
Provide a succinct answer. 0.59. What is the ratio of the Taxes (in $) in Zambia in 2003 to that in 2007?
Make the answer very short. 0.39. What is the ratio of the Taxes (in $) in Germany in 2003 to that in 2008?
Offer a very short reply. 0.86. What is the ratio of the Taxes (in $) of Switzerland in 2003 to that in 2008?
Ensure brevity in your answer.  0.82. What is the ratio of the Taxes (in $) in Trinidad and Tobago in 2003 to that in 2008?
Give a very brief answer. 0.46. What is the ratio of the Taxes (in $) in Zambia in 2003 to that in 2008?
Offer a terse response. 0.34. What is the ratio of the Taxes (in $) in Germany in 2003 to that in 2009?
Offer a terse response. 0.83. What is the ratio of the Taxes (in $) of Switzerland in 2003 to that in 2009?
Keep it short and to the point. 0.84. What is the ratio of the Taxes (in $) in Trinidad and Tobago in 2003 to that in 2009?
Give a very brief answer. 0.56. What is the ratio of the Taxes (in $) in Zambia in 2003 to that in 2009?
Provide a succinct answer. 0.37. What is the ratio of the Taxes (in $) of Germany in 2003 to that in 2010?
Provide a succinct answer. 0.81. What is the ratio of the Taxes (in $) in Switzerland in 2003 to that in 2010?
Ensure brevity in your answer.  0.95. What is the ratio of the Taxes (in $) in Trinidad and Tobago in 2003 to that in 2010?
Provide a succinct answer. 0.48. What is the ratio of the Taxes (in $) of Zambia in 2003 to that in 2010?
Ensure brevity in your answer.  0.29. What is the ratio of the Taxes (in $) in Germany in 2004 to that in 2005?
Your answer should be very brief. 0.97. What is the ratio of the Taxes (in $) in Switzerland in 2004 to that in 2005?
Keep it short and to the point. 0.96. What is the ratio of the Taxes (in $) of Trinidad and Tobago in 2004 to that in 2005?
Provide a short and direct response. 1. What is the ratio of the Taxes (in $) in Zambia in 2004 to that in 2005?
Ensure brevity in your answer.  0.85. What is the ratio of the Taxes (in $) of Germany in 2004 to that in 2006?
Offer a very short reply. 0.94. What is the ratio of the Taxes (in $) of Switzerland in 2004 to that in 2006?
Your answer should be compact. 0.92. What is the ratio of the Taxes (in $) of Trinidad and Tobago in 2004 to that in 2006?
Your answer should be compact. 0.86. What is the ratio of the Taxes (in $) in Zambia in 2004 to that in 2006?
Your answer should be compact. 0.75. What is the ratio of the Taxes (in $) in Germany in 2004 to that in 2007?
Provide a short and direct response. 0.86. What is the ratio of the Taxes (in $) of Switzerland in 2004 to that in 2007?
Offer a terse response. 0.9. What is the ratio of the Taxes (in $) of Trinidad and Tobago in 2004 to that in 2007?
Your response must be concise. 0.75. What is the ratio of the Taxes (in $) in Zambia in 2004 to that in 2007?
Keep it short and to the point. 0.55. What is the ratio of the Taxes (in $) of Germany in 2004 to that in 2008?
Offer a very short reply. 0.84. What is the ratio of the Taxes (in $) of Switzerland in 2004 to that in 2008?
Ensure brevity in your answer.  0.85. What is the ratio of the Taxes (in $) of Trinidad and Tobago in 2004 to that in 2008?
Your response must be concise. 0.59. What is the ratio of the Taxes (in $) in Zambia in 2004 to that in 2008?
Make the answer very short. 0.48. What is the ratio of the Taxes (in $) of Germany in 2004 to that in 2009?
Give a very brief answer. 0.81. What is the ratio of the Taxes (in $) in Switzerland in 2004 to that in 2009?
Your response must be concise. 0.88. What is the ratio of the Taxes (in $) in Trinidad and Tobago in 2004 to that in 2009?
Provide a succinct answer. 0.71. What is the ratio of the Taxes (in $) in Zambia in 2004 to that in 2009?
Make the answer very short. 0.52. What is the ratio of the Taxes (in $) in Germany in 2004 to that in 2010?
Your answer should be compact. 0.79. What is the ratio of the Taxes (in $) of Trinidad and Tobago in 2004 to that in 2010?
Provide a succinct answer. 0.62. What is the ratio of the Taxes (in $) of Zambia in 2004 to that in 2010?
Provide a short and direct response. 0.41. What is the ratio of the Taxes (in $) in Germany in 2005 to that in 2006?
Offer a terse response. 0.97. What is the ratio of the Taxes (in $) in Switzerland in 2005 to that in 2006?
Make the answer very short. 0.96. What is the ratio of the Taxes (in $) in Trinidad and Tobago in 2005 to that in 2006?
Give a very brief answer. 0.86. What is the ratio of the Taxes (in $) in Zambia in 2005 to that in 2006?
Provide a short and direct response. 0.88. What is the ratio of the Taxes (in $) of Germany in 2005 to that in 2007?
Your answer should be compact. 0.89. What is the ratio of the Taxes (in $) of Switzerland in 2005 to that in 2007?
Your answer should be compact. 0.93. What is the ratio of the Taxes (in $) in Trinidad and Tobago in 2005 to that in 2007?
Offer a terse response. 0.75. What is the ratio of the Taxes (in $) in Zambia in 2005 to that in 2007?
Offer a very short reply. 0.65. What is the ratio of the Taxes (in $) in Germany in 2005 to that in 2008?
Your answer should be very brief. 0.87. What is the ratio of the Taxes (in $) in Switzerland in 2005 to that in 2008?
Make the answer very short. 0.89. What is the ratio of the Taxes (in $) of Trinidad and Tobago in 2005 to that in 2008?
Your answer should be very brief. 0.59. What is the ratio of the Taxes (in $) of Zambia in 2005 to that in 2008?
Provide a short and direct response. 0.57. What is the ratio of the Taxes (in $) in Germany in 2005 to that in 2009?
Your answer should be very brief. 0.84. What is the ratio of the Taxes (in $) in Switzerland in 2005 to that in 2009?
Ensure brevity in your answer.  0.91. What is the ratio of the Taxes (in $) in Trinidad and Tobago in 2005 to that in 2009?
Provide a short and direct response. 0.71. What is the ratio of the Taxes (in $) in Zambia in 2005 to that in 2009?
Provide a short and direct response. 0.61. What is the ratio of the Taxes (in $) of Germany in 2005 to that in 2010?
Give a very brief answer. 0.82. What is the ratio of the Taxes (in $) of Switzerland in 2005 to that in 2010?
Ensure brevity in your answer.  1.03. What is the ratio of the Taxes (in $) in Trinidad and Tobago in 2005 to that in 2010?
Your answer should be compact. 0.62. What is the ratio of the Taxes (in $) of Zambia in 2005 to that in 2010?
Make the answer very short. 0.48. What is the ratio of the Taxes (in $) in Germany in 2006 to that in 2007?
Provide a succinct answer. 0.91. What is the ratio of the Taxes (in $) of Switzerland in 2006 to that in 2007?
Make the answer very short. 0.97. What is the ratio of the Taxes (in $) in Trinidad and Tobago in 2006 to that in 2007?
Make the answer very short. 0.88. What is the ratio of the Taxes (in $) of Zambia in 2006 to that in 2007?
Ensure brevity in your answer.  0.73. What is the ratio of the Taxes (in $) of Germany in 2006 to that in 2008?
Your response must be concise. 0.89. What is the ratio of the Taxes (in $) of Switzerland in 2006 to that in 2008?
Offer a very short reply. 0.92. What is the ratio of the Taxes (in $) of Trinidad and Tobago in 2006 to that in 2008?
Your answer should be very brief. 0.69. What is the ratio of the Taxes (in $) in Zambia in 2006 to that in 2008?
Your answer should be very brief. 0.65. What is the ratio of the Taxes (in $) in Germany in 2006 to that in 2009?
Offer a terse response. 0.86. What is the ratio of the Taxes (in $) in Switzerland in 2006 to that in 2009?
Offer a terse response. 0.95. What is the ratio of the Taxes (in $) of Trinidad and Tobago in 2006 to that in 2009?
Your answer should be compact. 0.83. What is the ratio of the Taxes (in $) in Zambia in 2006 to that in 2009?
Keep it short and to the point. 0.69. What is the ratio of the Taxes (in $) in Germany in 2006 to that in 2010?
Your answer should be very brief. 0.84. What is the ratio of the Taxes (in $) in Switzerland in 2006 to that in 2010?
Your answer should be compact. 1.07. What is the ratio of the Taxes (in $) in Trinidad and Tobago in 2006 to that in 2010?
Keep it short and to the point. 0.72. What is the ratio of the Taxes (in $) in Zambia in 2006 to that in 2010?
Make the answer very short. 0.54. What is the ratio of the Taxes (in $) of Germany in 2007 to that in 2008?
Offer a terse response. 0.98. What is the ratio of the Taxes (in $) of Switzerland in 2007 to that in 2008?
Ensure brevity in your answer.  0.95. What is the ratio of the Taxes (in $) in Trinidad and Tobago in 2007 to that in 2008?
Your answer should be compact. 0.79. What is the ratio of the Taxes (in $) in Zambia in 2007 to that in 2008?
Give a very brief answer. 0.88. What is the ratio of the Taxes (in $) of Germany in 2007 to that in 2009?
Your answer should be compact. 0.94. What is the ratio of the Taxes (in $) of Switzerland in 2007 to that in 2009?
Offer a terse response. 0.98. What is the ratio of the Taxes (in $) of Trinidad and Tobago in 2007 to that in 2009?
Provide a succinct answer. 0.95. What is the ratio of the Taxes (in $) in Zambia in 2007 to that in 2009?
Your answer should be compact. 0.95. What is the ratio of the Taxes (in $) of Germany in 2007 to that in 2010?
Offer a very short reply. 0.92. What is the ratio of the Taxes (in $) of Switzerland in 2007 to that in 2010?
Offer a terse response. 1.1. What is the ratio of the Taxes (in $) of Trinidad and Tobago in 2007 to that in 2010?
Offer a very short reply. 0.82. What is the ratio of the Taxes (in $) in Zambia in 2007 to that in 2010?
Offer a terse response. 0.74. What is the ratio of the Taxes (in $) in Germany in 2008 to that in 2009?
Provide a short and direct response. 0.96. What is the ratio of the Taxes (in $) of Switzerland in 2008 to that in 2009?
Ensure brevity in your answer.  1.03. What is the ratio of the Taxes (in $) in Trinidad and Tobago in 2008 to that in 2009?
Your answer should be compact. 1.2. What is the ratio of the Taxes (in $) of Zambia in 2008 to that in 2009?
Your response must be concise. 1.08. What is the ratio of the Taxes (in $) in Germany in 2008 to that in 2010?
Keep it short and to the point. 0.94. What is the ratio of the Taxes (in $) of Switzerland in 2008 to that in 2010?
Make the answer very short. 1.16. What is the ratio of the Taxes (in $) in Trinidad and Tobago in 2008 to that in 2010?
Your answer should be compact. 1.04. What is the ratio of the Taxes (in $) of Zambia in 2008 to that in 2010?
Your response must be concise. 0.84. What is the ratio of the Taxes (in $) of Germany in 2009 to that in 2010?
Offer a very short reply. 0.98. What is the ratio of the Taxes (in $) of Switzerland in 2009 to that in 2010?
Offer a very short reply. 1.13. What is the ratio of the Taxes (in $) of Trinidad and Tobago in 2009 to that in 2010?
Make the answer very short. 0.86. What is the ratio of the Taxes (in $) of Zambia in 2009 to that in 2010?
Make the answer very short. 0.78. What is the difference between the highest and the second highest Taxes (in $) in Germany?
Keep it short and to the point. 3.85e+09. What is the difference between the highest and the second highest Taxes (in $) in Switzerland?
Keep it short and to the point. 9.00e+08. What is the difference between the highest and the second highest Taxes (in $) in Trinidad and Tobago?
Keep it short and to the point. 2.76e+08. What is the difference between the highest and the second highest Taxes (in $) of Zambia?
Offer a very short reply. 7.88e+08. What is the difference between the highest and the lowest Taxes (in $) in Germany?
Your answer should be compact. 3.68e+1. What is the difference between the highest and the lowest Taxes (in $) of Switzerland?
Make the answer very short. 5.62e+09. What is the difference between the highest and the lowest Taxes (in $) of Trinidad and Tobago?
Ensure brevity in your answer.  4.10e+09. What is the difference between the highest and the lowest Taxes (in $) of Zambia?
Provide a succinct answer. 3.49e+09. 